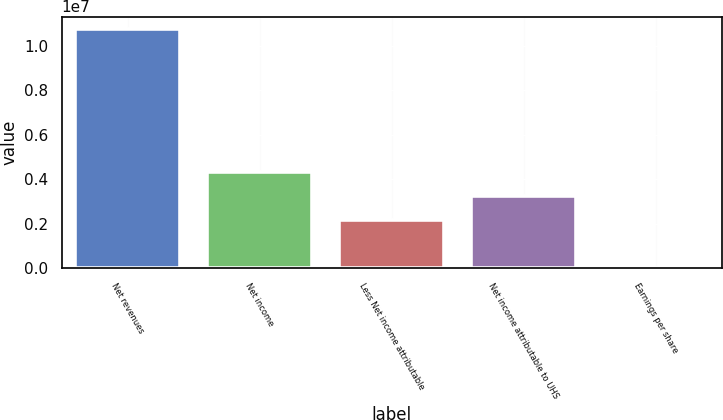Convert chart to OTSL. <chart><loc_0><loc_0><loc_500><loc_500><bar_chart><fcel>Net revenues<fcel>Net income<fcel>Less Net income attributable<fcel>Net income attributable to UHS<fcel>Earnings per share<nl><fcel>1.07723e+07<fcel>4.30892e+06<fcel>2.15446e+06<fcel>3.23169e+06<fcel>8.31<nl></chart> 